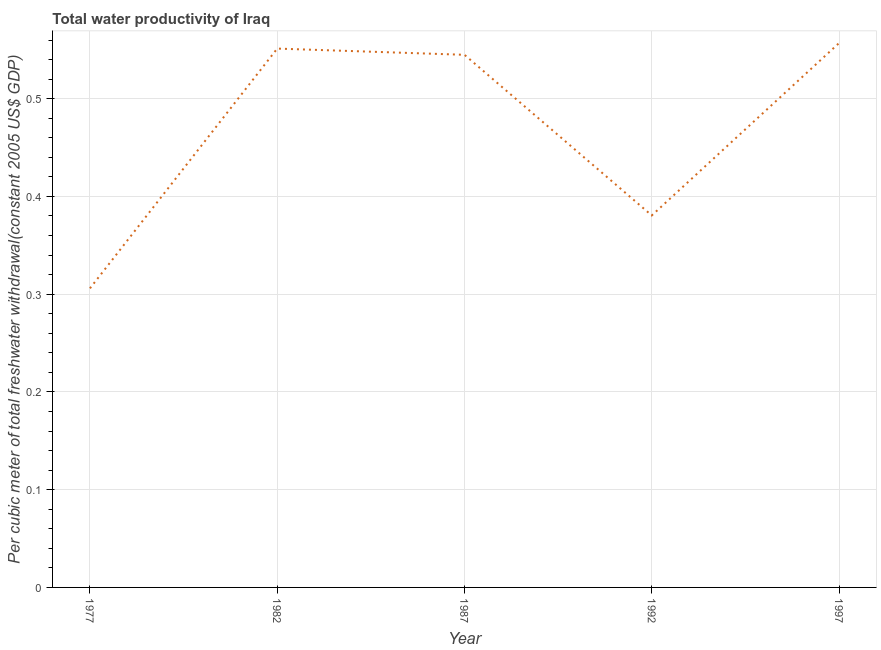What is the total water productivity in 1987?
Offer a very short reply. 0.54. Across all years, what is the maximum total water productivity?
Your answer should be very brief. 0.56. Across all years, what is the minimum total water productivity?
Your answer should be very brief. 0.31. In which year was the total water productivity maximum?
Give a very brief answer. 1997. In which year was the total water productivity minimum?
Your response must be concise. 1977. What is the sum of the total water productivity?
Offer a terse response. 2.34. What is the difference between the total water productivity in 1987 and 1992?
Make the answer very short. 0.16. What is the average total water productivity per year?
Your response must be concise. 0.47. What is the median total water productivity?
Keep it short and to the point. 0.54. In how many years, is the total water productivity greater than 0.52 US$?
Offer a very short reply. 3. What is the ratio of the total water productivity in 1982 to that in 1987?
Your answer should be very brief. 1.01. What is the difference between the highest and the second highest total water productivity?
Provide a succinct answer. 0.01. What is the difference between the highest and the lowest total water productivity?
Ensure brevity in your answer.  0.25. In how many years, is the total water productivity greater than the average total water productivity taken over all years?
Provide a succinct answer. 3. How many lines are there?
Make the answer very short. 1. What is the difference between two consecutive major ticks on the Y-axis?
Your response must be concise. 0.1. Does the graph contain any zero values?
Offer a very short reply. No. Does the graph contain grids?
Ensure brevity in your answer.  Yes. What is the title of the graph?
Ensure brevity in your answer.  Total water productivity of Iraq. What is the label or title of the Y-axis?
Ensure brevity in your answer.  Per cubic meter of total freshwater withdrawal(constant 2005 US$ GDP). What is the Per cubic meter of total freshwater withdrawal(constant 2005 US$ GDP) in 1977?
Offer a terse response. 0.31. What is the Per cubic meter of total freshwater withdrawal(constant 2005 US$ GDP) of 1982?
Provide a short and direct response. 0.55. What is the Per cubic meter of total freshwater withdrawal(constant 2005 US$ GDP) of 1987?
Offer a terse response. 0.54. What is the Per cubic meter of total freshwater withdrawal(constant 2005 US$ GDP) in 1992?
Offer a very short reply. 0.38. What is the Per cubic meter of total freshwater withdrawal(constant 2005 US$ GDP) of 1997?
Your answer should be very brief. 0.56. What is the difference between the Per cubic meter of total freshwater withdrawal(constant 2005 US$ GDP) in 1977 and 1982?
Your answer should be compact. -0.25. What is the difference between the Per cubic meter of total freshwater withdrawal(constant 2005 US$ GDP) in 1977 and 1987?
Provide a succinct answer. -0.24. What is the difference between the Per cubic meter of total freshwater withdrawal(constant 2005 US$ GDP) in 1977 and 1992?
Make the answer very short. -0.07. What is the difference between the Per cubic meter of total freshwater withdrawal(constant 2005 US$ GDP) in 1977 and 1997?
Give a very brief answer. -0.25. What is the difference between the Per cubic meter of total freshwater withdrawal(constant 2005 US$ GDP) in 1982 and 1987?
Your answer should be compact. 0.01. What is the difference between the Per cubic meter of total freshwater withdrawal(constant 2005 US$ GDP) in 1982 and 1992?
Your answer should be very brief. 0.17. What is the difference between the Per cubic meter of total freshwater withdrawal(constant 2005 US$ GDP) in 1982 and 1997?
Give a very brief answer. -0.01. What is the difference between the Per cubic meter of total freshwater withdrawal(constant 2005 US$ GDP) in 1987 and 1992?
Your answer should be compact. 0.16. What is the difference between the Per cubic meter of total freshwater withdrawal(constant 2005 US$ GDP) in 1987 and 1997?
Offer a terse response. -0.01. What is the difference between the Per cubic meter of total freshwater withdrawal(constant 2005 US$ GDP) in 1992 and 1997?
Make the answer very short. -0.18. What is the ratio of the Per cubic meter of total freshwater withdrawal(constant 2005 US$ GDP) in 1977 to that in 1982?
Ensure brevity in your answer.  0.56. What is the ratio of the Per cubic meter of total freshwater withdrawal(constant 2005 US$ GDP) in 1977 to that in 1987?
Offer a very short reply. 0.56. What is the ratio of the Per cubic meter of total freshwater withdrawal(constant 2005 US$ GDP) in 1977 to that in 1992?
Keep it short and to the point. 0.8. What is the ratio of the Per cubic meter of total freshwater withdrawal(constant 2005 US$ GDP) in 1977 to that in 1997?
Keep it short and to the point. 0.55. What is the ratio of the Per cubic meter of total freshwater withdrawal(constant 2005 US$ GDP) in 1982 to that in 1987?
Offer a very short reply. 1.01. What is the ratio of the Per cubic meter of total freshwater withdrawal(constant 2005 US$ GDP) in 1982 to that in 1992?
Offer a very short reply. 1.45. What is the ratio of the Per cubic meter of total freshwater withdrawal(constant 2005 US$ GDP) in 1987 to that in 1992?
Your response must be concise. 1.43. What is the ratio of the Per cubic meter of total freshwater withdrawal(constant 2005 US$ GDP) in 1987 to that in 1997?
Your answer should be compact. 0.98. What is the ratio of the Per cubic meter of total freshwater withdrawal(constant 2005 US$ GDP) in 1992 to that in 1997?
Give a very brief answer. 0.68. 